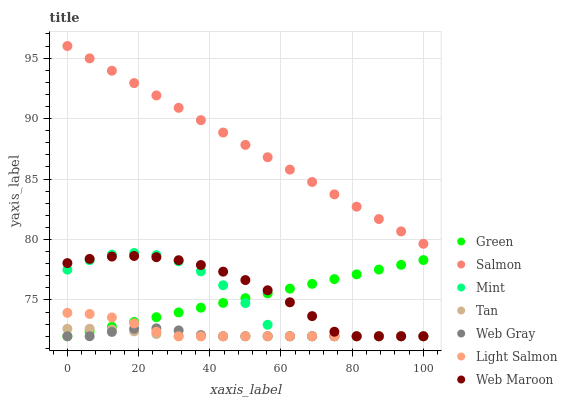Does Tan have the minimum area under the curve?
Answer yes or no. Yes. Does Salmon have the maximum area under the curve?
Answer yes or no. Yes. Does Web Gray have the minimum area under the curve?
Answer yes or no. No. Does Web Gray have the maximum area under the curve?
Answer yes or no. No. Is Green the smoothest?
Answer yes or no. Yes. Is Mint the roughest?
Answer yes or no. Yes. Is Web Gray the smoothest?
Answer yes or no. No. Is Web Gray the roughest?
Answer yes or no. No. Does Light Salmon have the lowest value?
Answer yes or no. Yes. Does Salmon have the lowest value?
Answer yes or no. No. Does Salmon have the highest value?
Answer yes or no. Yes. Does Web Gray have the highest value?
Answer yes or no. No. Is Light Salmon less than Salmon?
Answer yes or no. Yes. Is Salmon greater than Web Maroon?
Answer yes or no. Yes. Does Green intersect Tan?
Answer yes or no. Yes. Is Green less than Tan?
Answer yes or no. No. Is Green greater than Tan?
Answer yes or no. No. Does Light Salmon intersect Salmon?
Answer yes or no. No. 